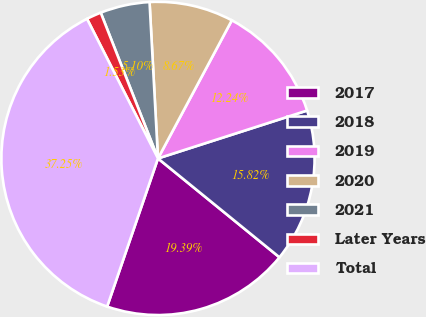Convert chart to OTSL. <chart><loc_0><loc_0><loc_500><loc_500><pie_chart><fcel>2017<fcel>2018<fcel>2019<fcel>2020<fcel>2021<fcel>Later Years<fcel>Total<nl><fcel>19.39%<fcel>15.82%<fcel>12.24%<fcel>8.67%<fcel>5.1%<fcel>1.53%<fcel>37.25%<nl></chart> 